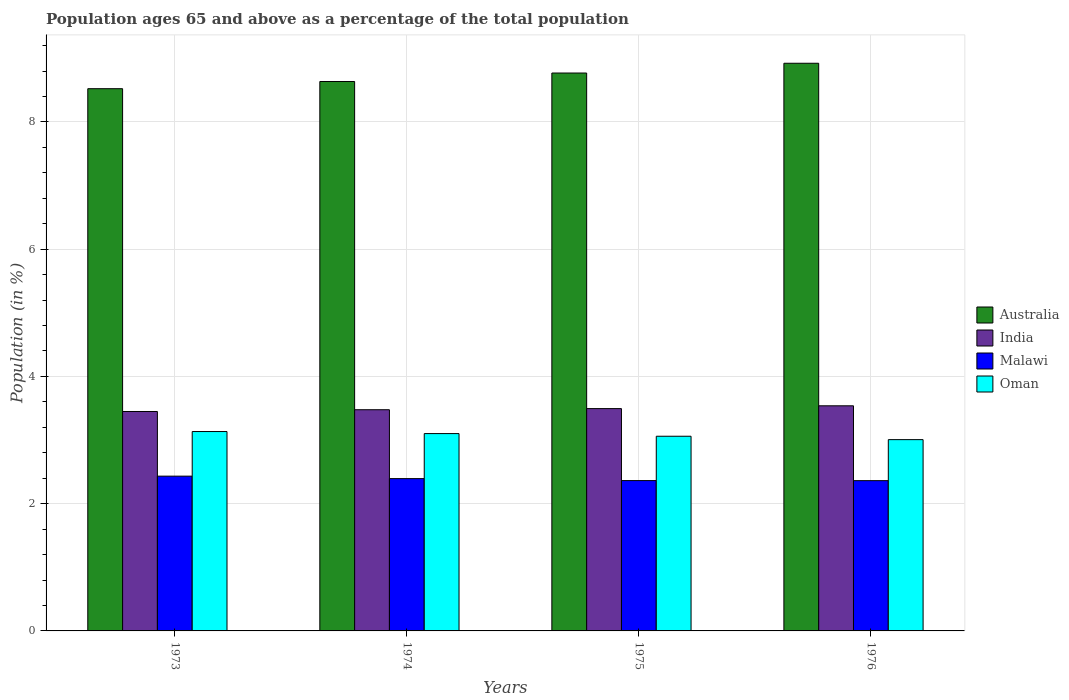How many different coloured bars are there?
Your response must be concise. 4. Are the number of bars on each tick of the X-axis equal?
Give a very brief answer. Yes. What is the label of the 4th group of bars from the left?
Your answer should be very brief. 1976. What is the percentage of the population ages 65 and above in Malawi in 1976?
Offer a very short reply. 2.36. Across all years, what is the maximum percentage of the population ages 65 and above in Malawi?
Provide a short and direct response. 2.43. Across all years, what is the minimum percentage of the population ages 65 and above in Malawi?
Your response must be concise. 2.36. In which year was the percentage of the population ages 65 and above in Oman minimum?
Give a very brief answer. 1976. What is the total percentage of the population ages 65 and above in Australia in the graph?
Your response must be concise. 34.85. What is the difference between the percentage of the population ages 65 and above in Oman in 1973 and that in 1975?
Your response must be concise. 0.07. What is the difference between the percentage of the population ages 65 and above in India in 1975 and the percentage of the population ages 65 and above in Oman in 1973?
Ensure brevity in your answer.  0.36. What is the average percentage of the population ages 65 and above in Australia per year?
Your answer should be very brief. 8.71. In the year 1974, what is the difference between the percentage of the population ages 65 and above in Oman and percentage of the population ages 65 and above in Australia?
Give a very brief answer. -5.53. In how many years, is the percentage of the population ages 65 and above in Malawi greater than 6.4?
Your answer should be compact. 0. What is the ratio of the percentage of the population ages 65 and above in Oman in 1973 to that in 1974?
Your response must be concise. 1.01. Is the percentage of the population ages 65 and above in Oman in 1973 less than that in 1975?
Your answer should be compact. No. Is the difference between the percentage of the population ages 65 and above in Oman in 1974 and 1975 greater than the difference between the percentage of the population ages 65 and above in Australia in 1974 and 1975?
Your answer should be compact. Yes. What is the difference between the highest and the second highest percentage of the population ages 65 and above in India?
Offer a very short reply. 0.04. What is the difference between the highest and the lowest percentage of the population ages 65 and above in Australia?
Make the answer very short. 0.4. In how many years, is the percentage of the population ages 65 and above in Australia greater than the average percentage of the population ages 65 and above in Australia taken over all years?
Keep it short and to the point. 2. Is it the case that in every year, the sum of the percentage of the population ages 65 and above in Oman and percentage of the population ages 65 and above in Malawi is greater than the sum of percentage of the population ages 65 and above in India and percentage of the population ages 65 and above in Australia?
Make the answer very short. No. What does the 1st bar from the right in 1975 represents?
Ensure brevity in your answer.  Oman. Is it the case that in every year, the sum of the percentage of the population ages 65 and above in India and percentage of the population ages 65 and above in Australia is greater than the percentage of the population ages 65 and above in Malawi?
Your answer should be very brief. Yes. Does the graph contain any zero values?
Your response must be concise. No. Does the graph contain grids?
Make the answer very short. Yes. Where does the legend appear in the graph?
Offer a terse response. Center right. What is the title of the graph?
Offer a very short reply. Population ages 65 and above as a percentage of the total population. What is the label or title of the X-axis?
Your response must be concise. Years. What is the Population (in %) of Australia in 1973?
Provide a succinct answer. 8.52. What is the Population (in %) of India in 1973?
Give a very brief answer. 3.45. What is the Population (in %) in Malawi in 1973?
Provide a succinct answer. 2.43. What is the Population (in %) of Oman in 1973?
Your response must be concise. 3.13. What is the Population (in %) in Australia in 1974?
Offer a terse response. 8.64. What is the Population (in %) in India in 1974?
Your response must be concise. 3.48. What is the Population (in %) of Malawi in 1974?
Your response must be concise. 2.39. What is the Population (in %) in Oman in 1974?
Give a very brief answer. 3.1. What is the Population (in %) in Australia in 1975?
Your answer should be compact. 8.77. What is the Population (in %) of India in 1975?
Provide a short and direct response. 3.49. What is the Population (in %) in Malawi in 1975?
Your answer should be very brief. 2.36. What is the Population (in %) in Oman in 1975?
Your answer should be compact. 3.06. What is the Population (in %) of Australia in 1976?
Keep it short and to the point. 8.92. What is the Population (in %) in India in 1976?
Offer a terse response. 3.54. What is the Population (in %) of Malawi in 1976?
Offer a very short reply. 2.36. What is the Population (in %) in Oman in 1976?
Provide a short and direct response. 3.01. Across all years, what is the maximum Population (in %) in Australia?
Your answer should be compact. 8.92. Across all years, what is the maximum Population (in %) of India?
Ensure brevity in your answer.  3.54. Across all years, what is the maximum Population (in %) in Malawi?
Offer a terse response. 2.43. Across all years, what is the maximum Population (in %) of Oman?
Give a very brief answer. 3.13. Across all years, what is the minimum Population (in %) in Australia?
Provide a succinct answer. 8.52. Across all years, what is the minimum Population (in %) in India?
Ensure brevity in your answer.  3.45. Across all years, what is the minimum Population (in %) in Malawi?
Make the answer very short. 2.36. Across all years, what is the minimum Population (in %) of Oman?
Ensure brevity in your answer.  3.01. What is the total Population (in %) in Australia in the graph?
Your answer should be compact. 34.85. What is the total Population (in %) of India in the graph?
Your answer should be compact. 13.96. What is the total Population (in %) of Malawi in the graph?
Offer a terse response. 9.55. What is the total Population (in %) in Oman in the graph?
Offer a very short reply. 12.3. What is the difference between the Population (in %) of Australia in 1973 and that in 1974?
Provide a short and direct response. -0.11. What is the difference between the Population (in %) in India in 1973 and that in 1974?
Your answer should be very brief. -0.03. What is the difference between the Population (in %) in Malawi in 1973 and that in 1974?
Provide a succinct answer. 0.04. What is the difference between the Population (in %) in Oman in 1973 and that in 1974?
Offer a terse response. 0.03. What is the difference between the Population (in %) of Australia in 1973 and that in 1975?
Make the answer very short. -0.25. What is the difference between the Population (in %) in India in 1973 and that in 1975?
Provide a succinct answer. -0.05. What is the difference between the Population (in %) of Malawi in 1973 and that in 1975?
Provide a short and direct response. 0.07. What is the difference between the Population (in %) in Oman in 1973 and that in 1975?
Give a very brief answer. 0.07. What is the difference between the Population (in %) in Australia in 1973 and that in 1976?
Make the answer very short. -0.4. What is the difference between the Population (in %) in India in 1973 and that in 1976?
Your answer should be compact. -0.09. What is the difference between the Population (in %) of Malawi in 1973 and that in 1976?
Make the answer very short. 0.07. What is the difference between the Population (in %) in Oman in 1973 and that in 1976?
Offer a terse response. 0.13. What is the difference between the Population (in %) in Australia in 1974 and that in 1975?
Your answer should be very brief. -0.13. What is the difference between the Population (in %) in India in 1974 and that in 1975?
Provide a succinct answer. -0.02. What is the difference between the Population (in %) in Malawi in 1974 and that in 1975?
Provide a short and direct response. 0.03. What is the difference between the Population (in %) in Oman in 1974 and that in 1975?
Offer a very short reply. 0.04. What is the difference between the Population (in %) of Australia in 1974 and that in 1976?
Your answer should be compact. -0.29. What is the difference between the Population (in %) in India in 1974 and that in 1976?
Offer a terse response. -0.06. What is the difference between the Population (in %) in Malawi in 1974 and that in 1976?
Ensure brevity in your answer.  0.03. What is the difference between the Population (in %) of Oman in 1974 and that in 1976?
Provide a succinct answer. 0.09. What is the difference between the Population (in %) in Australia in 1975 and that in 1976?
Ensure brevity in your answer.  -0.15. What is the difference between the Population (in %) of India in 1975 and that in 1976?
Ensure brevity in your answer.  -0.04. What is the difference between the Population (in %) of Malawi in 1975 and that in 1976?
Make the answer very short. 0. What is the difference between the Population (in %) in Oman in 1975 and that in 1976?
Give a very brief answer. 0.05. What is the difference between the Population (in %) in Australia in 1973 and the Population (in %) in India in 1974?
Make the answer very short. 5.05. What is the difference between the Population (in %) in Australia in 1973 and the Population (in %) in Malawi in 1974?
Give a very brief answer. 6.13. What is the difference between the Population (in %) of Australia in 1973 and the Population (in %) of Oman in 1974?
Make the answer very short. 5.42. What is the difference between the Population (in %) in India in 1973 and the Population (in %) in Malawi in 1974?
Provide a succinct answer. 1.06. What is the difference between the Population (in %) of India in 1973 and the Population (in %) of Oman in 1974?
Offer a very short reply. 0.35. What is the difference between the Population (in %) of Malawi in 1973 and the Population (in %) of Oman in 1974?
Offer a very short reply. -0.67. What is the difference between the Population (in %) in Australia in 1973 and the Population (in %) in India in 1975?
Make the answer very short. 5.03. What is the difference between the Population (in %) in Australia in 1973 and the Population (in %) in Malawi in 1975?
Ensure brevity in your answer.  6.16. What is the difference between the Population (in %) in Australia in 1973 and the Population (in %) in Oman in 1975?
Make the answer very short. 5.46. What is the difference between the Population (in %) of India in 1973 and the Population (in %) of Malawi in 1975?
Offer a terse response. 1.09. What is the difference between the Population (in %) in India in 1973 and the Population (in %) in Oman in 1975?
Your response must be concise. 0.39. What is the difference between the Population (in %) in Malawi in 1973 and the Population (in %) in Oman in 1975?
Provide a succinct answer. -0.63. What is the difference between the Population (in %) of Australia in 1973 and the Population (in %) of India in 1976?
Your response must be concise. 4.98. What is the difference between the Population (in %) of Australia in 1973 and the Population (in %) of Malawi in 1976?
Provide a short and direct response. 6.16. What is the difference between the Population (in %) of Australia in 1973 and the Population (in %) of Oman in 1976?
Give a very brief answer. 5.52. What is the difference between the Population (in %) in India in 1973 and the Population (in %) in Malawi in 1976?
Your answer should be very brief. 1.09. What is the difference between the Population (in %) of India in 1973 and the Population (in %) of Oman in 1976?
Offer a terse response. 0.44. What is the difference between the Population (in %) in Malawi in 1973 and the Population (in %) in Oman in 1976?
Make the answer very short. -0.57. What is the difference between the Population (in %) in Australia in 1974 and the Population (in %) in India in 1975?
Offer a terse response. 5.14. What is the difference between the Population (in %) of Australia in 1974 and the Population (in %) of Malawi in 1975?
Give a very brief answer. 6.27. What is the difference between the Population (in %) of Australia in 1974 and the Population (in %) of Oman in 1975?
Give a very brief answer. 5.58. What is the difference between the Population (in %) of India in 1974 and the Population (in %) of Malawi in 1975?
Offer a very short reply. 1.11. What is the difference between the Population (in %) in India in 1974 and the Population (in %) in Oman in 1975?
Your answer should be compact. 0.42. What is the difference between the Population (in %) of Malawi in 1974 and the Population (in %) of Oman in 1975?
Give a very brief answer. -0.67. What is the difference between the Population (in %) of Australia in 1974 and the Population (in %) of India in 1976?
Ensure brevity in your answer.  5.1. What is the difference between the Population (in %) of Australia in 1974 and the Population (in %) of Malawi in 1976?
Your answer should be very brief. 6.27. What is the difference between the Population (in %) in Australia in 1974 and the Population (in %) in Oman in 1976?
Offer a terse response. 5.63. What is the difference between the Population (in %) in India in 1974 and the Population (in %) in Malawi in 1976?
Provide a short and direct response. 1.11. What is the difference between the Population (in %) of India in 1974 and the Population (in %) of Oman in 1976?
Provide a short and direct response. 0.47. What is the difference between the Population (in %) of Malawi in 1974 and the Population (in %) of Oman in 1976?
Provide a short and direct response. -0.61. What is the difference between the Population (in %) of Australia in 1975 and the Population (in %) of India in 1976?
Your answer should be very brief. 5.23. What is the difference between the Population (in %) of Australia in 1975 and the Population (in %) of Malawi in 1976?
Provide a succinct answer. 6.41. What is the difference between the Population (in %) of Australia in 1975 and the Population (in %) of Oman in 1976?
Your response must be concise. 5.76. What is the difference between the Population (in %) of India in 1975 and the Population (in %) of Malawi in 1976?
Provide a succinct answer. 1.13. What is the difference between the Population (in %) of India in 1975 and the Population (in %) of Oman in 1976?
Give a very brief answer. 0.49. What is the difference between the Population (in %) of Malawi in 1975 and the Population (in %) of Oman in 1976?
Ensure brevity in your answer.  -0.64. What is the average Population (in %) in Australia per year?
Your answer should be very brief. 8.71. What is the average Population (in %) in India per year?
Provide a succinct answer. 3.49. What is the average Population (in %) of Malawi per year?
Give a very brief answer. 2.39. What is the average Population (in %) of Oman per year?
Provide a succinct answer. 3.08. In the year 1973, what is the difference between the Population (in %) of Australia and Population (in %) of India?
Your response must be concise. 5.07. In the year 1973, what is the difference between the Population (in %) in Australia and Population (in %) in Malawi?
Your answer should be compact. 6.09. In the year 1973, what is the difference between the Population (in %) of Australia and Population (in %) of Oman?
Offer a very short reply. 5.39. In the year 1973, what is the difference between the Population (in %) of India and Population (in %) of Malawi?
Your response must be concise. 1.02. In the year 1973, what is the difference between the Population (in %) in India and Population (in %) in Oman?
Provide a short and direct response. 0.32. In the year 1973, what is the difference between the Population (in %) in Malawi and Population (in %) in Oman?
Give a very brief answer. -0.7. In the year 1974, what is the difference between the Population (in %) of Australia and Population (in %) of India?
Provide a short and direct response. 5.16. In the year 1974, what is the difference between the Population (in %) of Australia and Population (in %) of Malawi?
Ensure brevity in your answer.  6.24. In the year 1974, what is the difference between the Population (in %) in Australia and Population (in %) in Oman?
Offer a very short reply. 5.53. In the year 1974, what is the difference between the Population (in %) of India and Population (in %) of Malawi?
Provide a short and direct response. 1.08. In the year 1974, what is the difference between the Population (in %) in India and Population (in %) in Oman?
Your answer should be very brief. 0.38. In the year 1974, what is the difference between the Population (in %) in Malawi and Population (in %) in Oman?
Offer a very short reply. -0.71. In the year 1975, what is the difference between the Population (in %) in Australia and Population (in %) in India?
Offer a terse response. 5.27. In the year 1975, what is the difference between the Population (in %) in Australia and Population (in %) in Malawi?
Offer a terse response. 6.41. In the year 1975, what is the difference between the Population (in %) of Australia and Population (in %) of Oman?
Ensure brevity in your answer.  5.71. In the year 1975, what is the difference between the Population (in %) of India and Population (in %) of Malawi?
Keep it short and to the point. 1.13. In the year 1975, what is the difference between the Population (in %) of India and Population (in %) of Oman?
Your answer should be compact. 0.43. In the year 1975, what is the difference between the Population (in %) of Malawi and Population (in %) of Oman?
Offer a very short reply. -0.7. In the year 1976, what is the difference between the Population (in %) of Australia and Population (in %) of India?
Provide a short and direct response. 5.38. In the year 1976, what is the difference between the Population (in %) in Australia and Population (in %) in Malawi?
Offer a very short reply. 6.56. In the year 1976, what is the difference between the Population (in %) in Australia and Population (in %) in Oman?
Provide a succinct answer. 5.92. In the year 1976, what is the difference between the Population (in %) of India and Population (in %) of Malawi?
Give a very brief answer. 1.18. In the year 1976, what is the difference between the Population (in %) of India and Population (in %) of Oman?
Give a very brief answer. 0.53. In the year 1976, what is the difference between the Population (in %) of Malawi and Population (in %) of Oman?
Your answer should be compact. -0.64. What is the ratio of the Population (in %) of Australia in 1973 to that in 1974?
Your answer should be compact. 0.99. What is the ratio of the Population (in %) in India in 1973 to that in 1974?
Offer a terse response. 0.99. What is the ratio of the Population (in %) in Malawi in 1973 to that in 1974?
Provide a short and direct response. 1.02. What is the ratio of the Population (in %) of Oman in 1973 to that in 1974?
Offer a terse response. 1.01. What is the ratio of the Population (in %) of Australia in 1973 to that in 1975?
Offer a very short reply. 0.97. What is the ratio of the Population (in %) of India in 1973 to that in 1975?
Provide a short and direct response. 0.99. What is the ratio of the Population (in %) of Malawi in 1973 to that in 1975?
Offer a very short reply. 1.03. What is the ratio of the Population (in %) of Oman in 1973 to that in 1975?
Give a very brief answer. 1.02. What is the ratio of the Population (in %) in Australia in 1973 to that in 1976?
Your answer should be compact. 0.96. What is the ratio of the Population (in %) of India in 1973 to that in 1976?
Provide a short and direct response. 0.97. What is the ratio of the Population (in %) in Malawi in 1973 to that in 1976?
Offer a terse response. 1.03. What is the ratio of the Population (in %) of Oman in 1973 to that in 1976?
Offer a terse response. 1.04. What is the ratio of the Population (in %) in Australia in 1974 to that in 1975?
Your answer should be very brief. 0.98. What is the ratio of the Population (in %) in Malawi in 1974 to that in 1975?
Provide a succinct answer. 1.01. What is the ratio of the Population (in %) of Oman in 1974 to that in 1975?
Give a very brief answer. 1.01. What is the ratio of the Population (in %) of Australia in 1974 to that in 1976?
Give a very brief answer. 0.97. What is the ratio of the Population (in %) of India in 1974 to that in 1976?
Ensure brevity in your answer.  0.98. What is the ratio of the Population (in %) of Malawi in 1974 to that in 1976?
Keep it short and to the point. 1.01. What is the ratio of the Population (in %) in Oman in 1974 to that in 1976?
Provide a short and direct response. 1.03. What is the ratio of the Population (in %) of Australia in 1975 to that in 1976?
Your answer should be compact. 0.98. What is the ratio of the Population (in %) of India in 1975 to that in 1976?
Your answer should be very brief. 0.99. What is the ratio of the Population (in %) of Malawi in 1975 to that in 1976?
Provide a short and direct response. 1. What is the ratio of the Population (in %) in Oman in 1975 to that in 1976?
Ensure brevity in your answer.  1.02. What is the difference between the highest and the second highest Population (in %) in Australia?
Offer a terse response. 0.15. What is the difference between the highest and the second highest Population (in %) in India?
Your response must be concise. 0.04. What is the difference between the highest and the second highest Population (in %) of Malawi?
Ensure brevity in your answer.  0.04. What is the difference between the highest and the second highest Population (in %) in Oman?
Your response must be concise. 0.03. What is the difference between the highest and the lowest Population (in %) of Australia?
Your response must be concise. 0.4. What is the difference between the highest and the lowest Population (in %) of India?
Your answer should be compact. 0.09. What is the difference between the highest and the lowest Population (in %) of Malawi?
Offer a very short reply. 0.07. What is the difference between the highest and the lowest Population (in %) of Oman?
Ensure brevity in your answer.  0.13. 